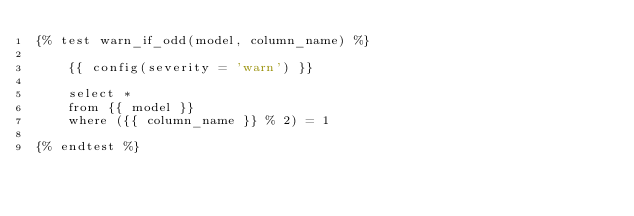<code> <loc_0><loc_0><loc_500><loc_500><_SQL_>{% test warn_if_odd(model, column_name) %}

    {{ config(severity = 'warn') }}

    select *
    from {{ model }}
    where ({{ column_name }} % 2) = 1

{% endtest %}
</code> 